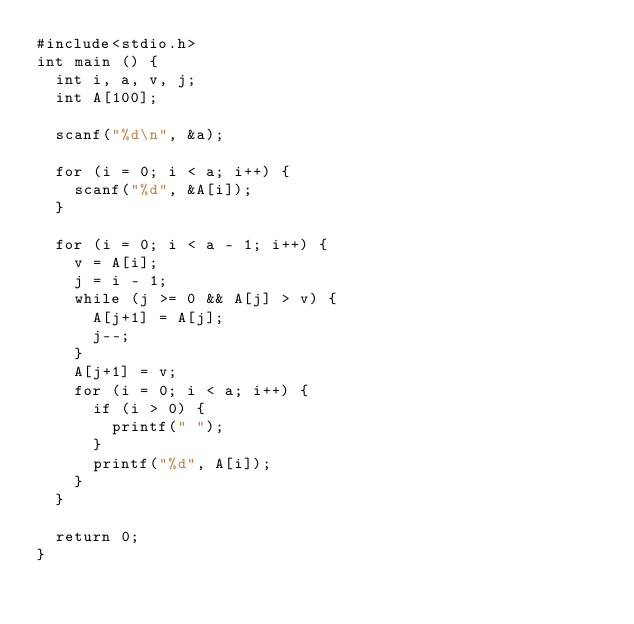Convert code to text. <code><loc_0><loc_0><loc_500><loc_500><_C_>#include<stdio.h>
int main () {
  int i, a, v, j;
  int A[100];

  scanf("%d\n", &a);

  for (i = 0; i < a; i++) {
    scanf("%d", &A[i]);
  }

  for (i = 0; i < a - 1; i++) {
    v = A[i];
    j = i - 1;
    while (j >= 0 && A[j] > v) {
      A[j+1] = A[j];
      j--;
    }
    A[j+1] = v;
    for (i = 0; i < a; i++) {
      if (i > 0) {
        printf(" ");
      }
      printf("%d", A[i]);
    }
  }

  return 0;
}</code> 